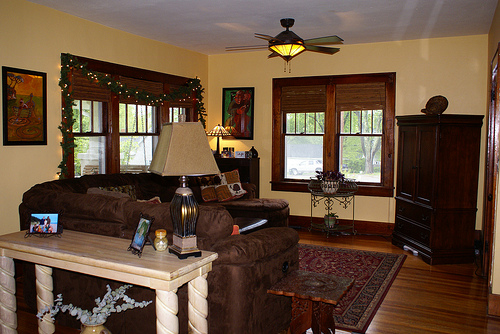Please provide a short description for this region: [0.07, 0.73, 0.31, 0.83]. A gracefully arranged white flower in a vase. 